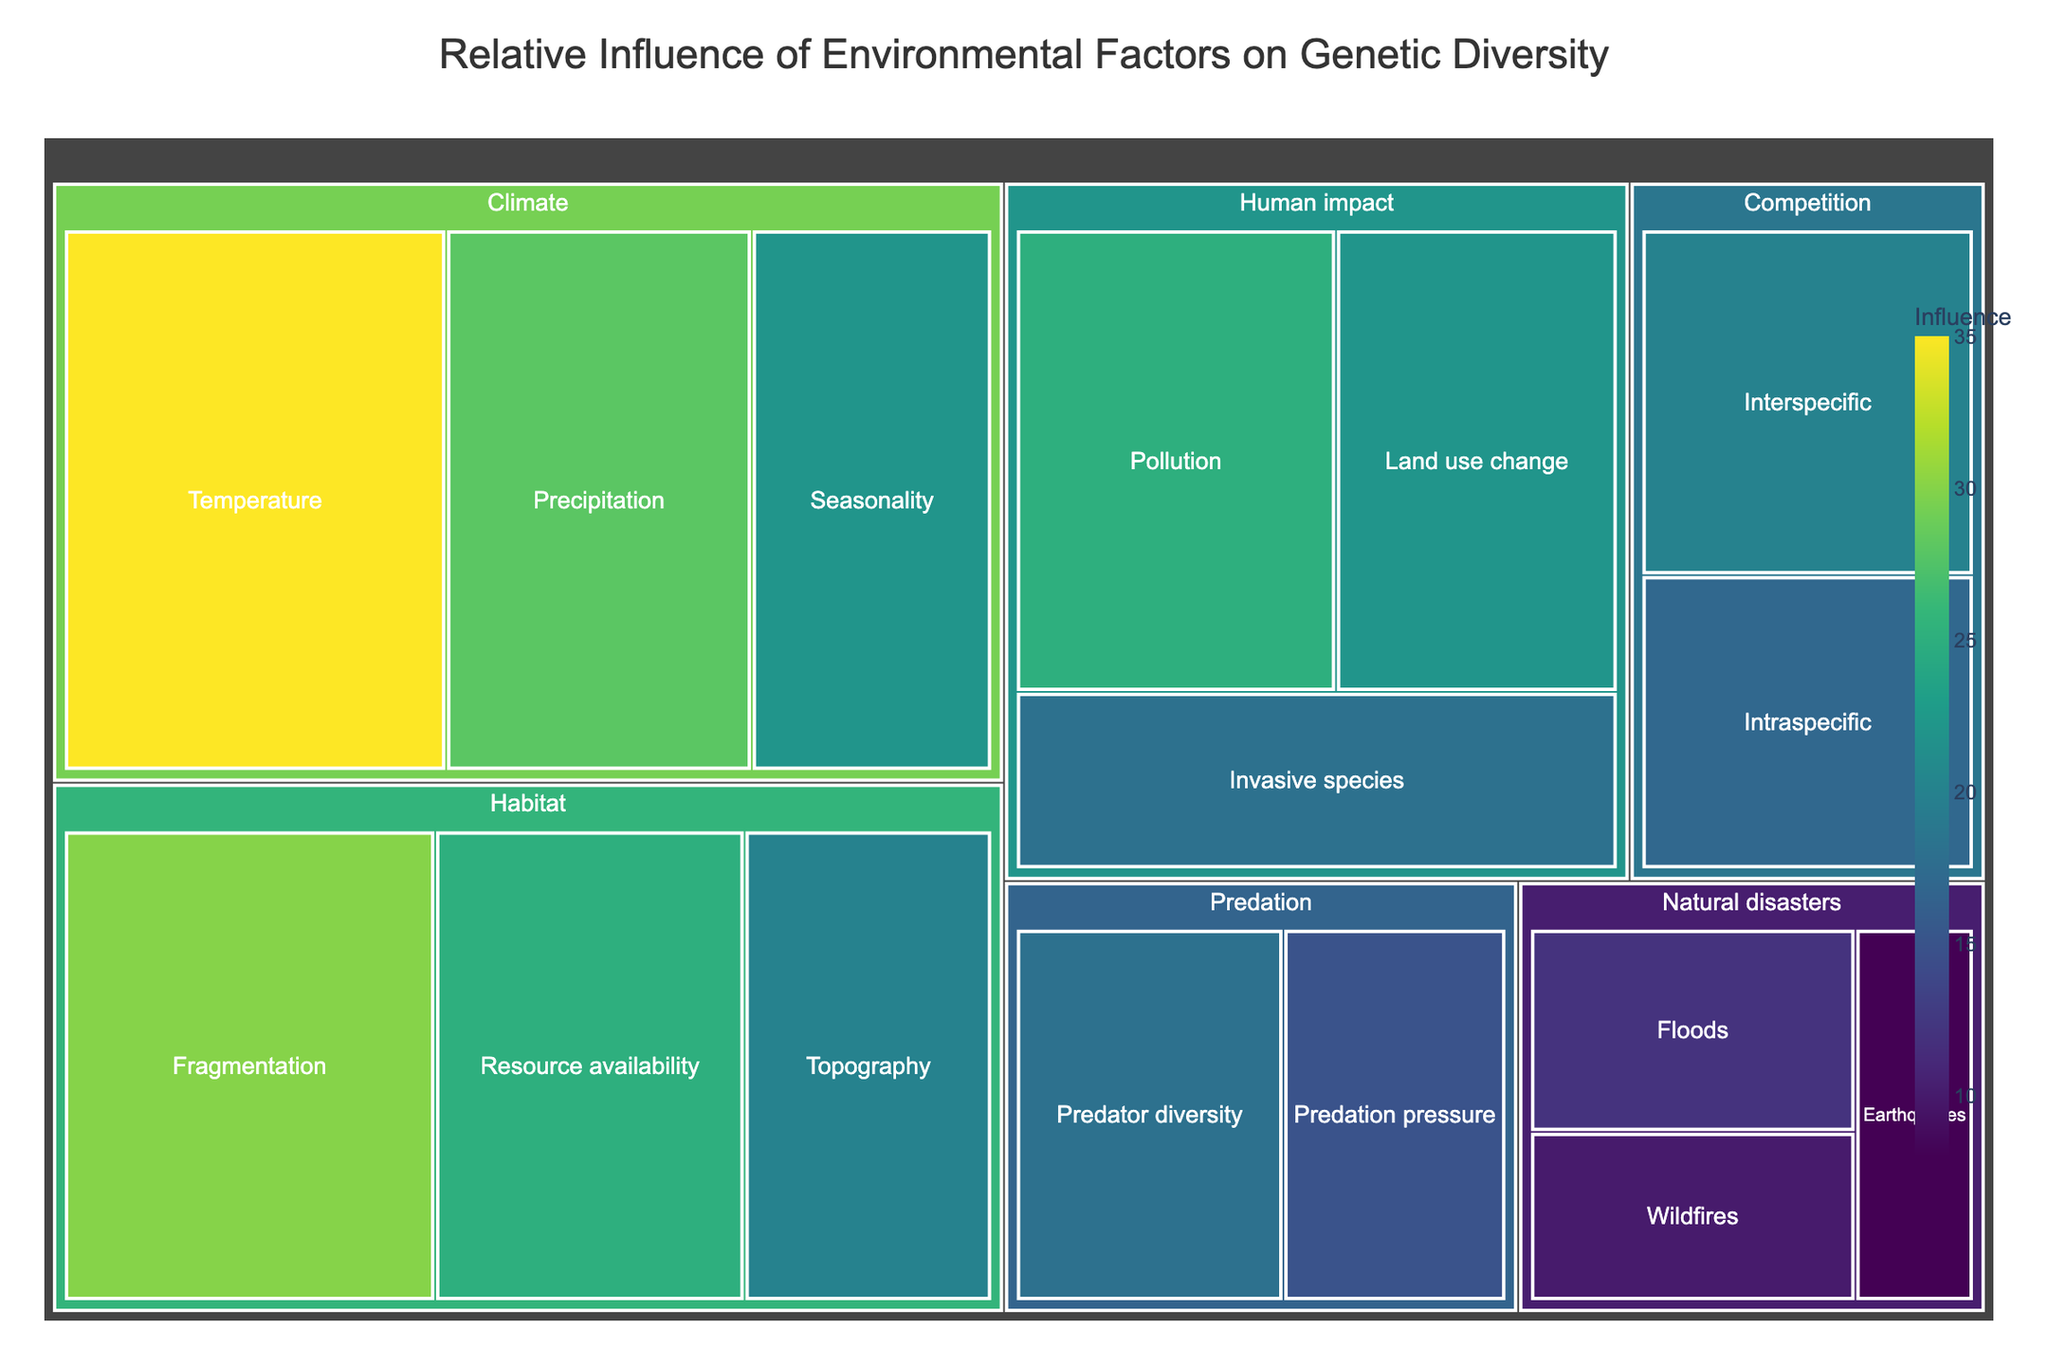What is the title of the treemap? The title is usually displayed at the top of the figure. In this case, it reads "Relative Influence of Environmental Factors on Genetic Diversity".
Answer: Relative Influence of Environmental Factors on Genetic Diversity Which subcategory under 'Climate' has the highest influence value? Under the 'Climate' category, the subcategory with the highest value can be found by comparing the values. Temperature has a value of 35, which is the highest.
Answer: Temperature What is the total influence value for the 'Habitat' category? Add the values of the subcategories under 'Habitat' (Fragmentation: 30, Resource availability: 25, Topography: 20) to get the total. So, 30 + 25 + 20 = 75.
Answer: 75 How does the influence of 'Pollution' compare to 'Land use change'? Compare the values of 'Pollution' (25) and 'Land use change' (22). Pollution has a higher influence.
Answer: Pollution has a higher influence Which subcategory under 'Natural disasters' has the lowest influence? Look at the subcategories under 'Natural disasters' and compare their values (Floods: 12, Wildfires: 10, Earthquakes: 8). Earthquakes have the lowest value.
Answer: Earthquakes What is the combined influence of 'Predator diversity', 'Interspecific', and 'Seasonality'? Add the values of 'Predator diversity' (18), 'Interspecific' (20), and 'Seasonality' (22). The total is 18 + 20 + 22 = 60.
Answer: 60 What percentage of the total influence is attributed to 'Climate'? First, calculate the total value of all subcategories, then find the total value for 'Climate'. The total for all is 35+28+22+30+25+20+18+15+20+17+25+22+18+12+10+8 = 325. The total for 'Climate' is 35+28+22 = 85. The percentage is (85/325) * 100 ≈ 26.15%.
Answer: 26.15% Which category displays the highest single subcategory influence value? Identify the highest value across all subcategories and find its category. Temperature under 'Climate' has the highest single value of 35.
Answer: Climate Is the influence of 'Pollution' closer to 'Seasonality' or 'Resource availability'? Compare the value of 'Pollution' (25) with 'Seasonality' (22) and 'Resource availability' (25). Pollution and Resource availability are equal.
Answer: Resource availability What is the average influence value of all subcategories in 'Human impact'? Add the values of 'Pollution' (25), 'Land use change' (22), 'Invasive species' (18), then divide by the number of subcategories (3). The average is (25 + 22 + 18) / 3 = 21.7.
Answer: 21.7 